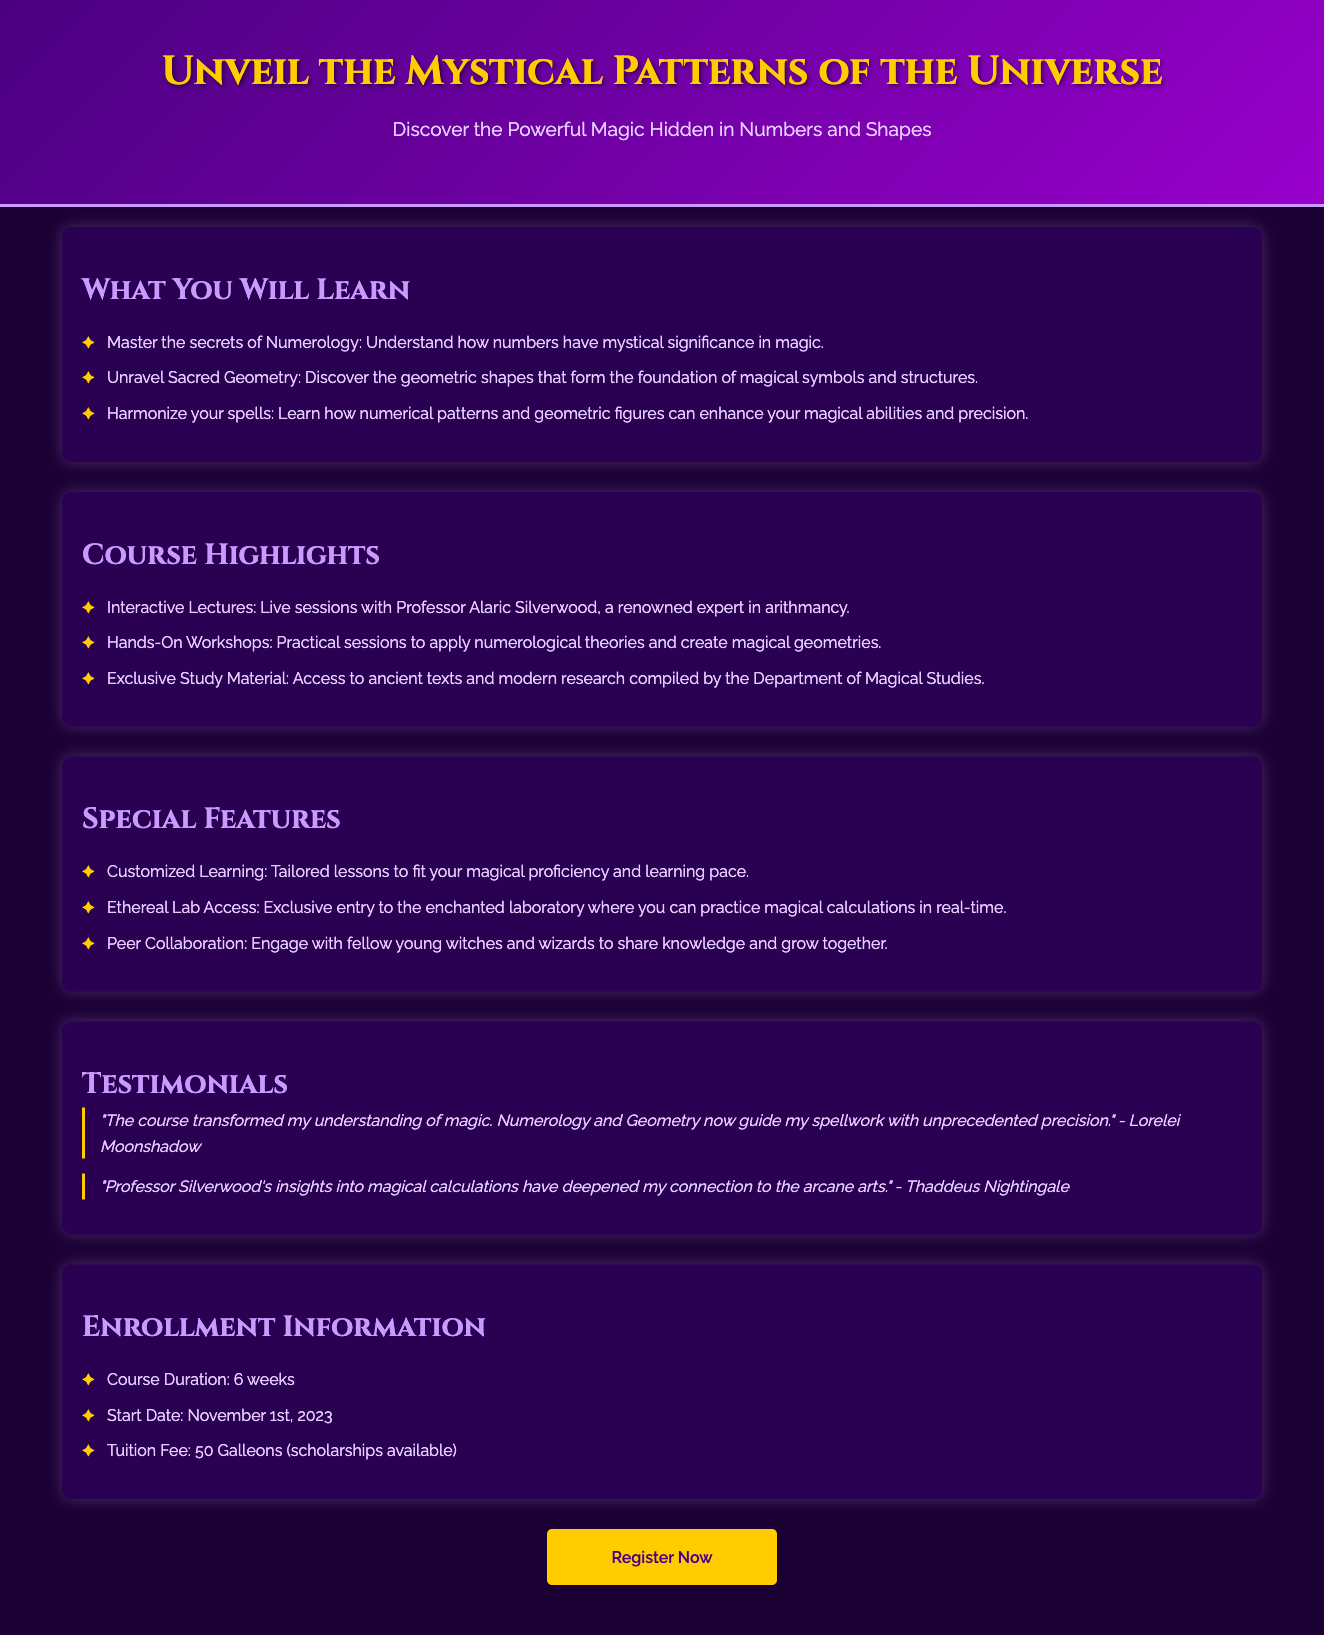What is the title of the course? The title of the course is prominently displayed in the header section of the document.
Answer: Spellbinding Symmetry Who is the instructor of the course? The instructor's name is mentioned in the course highlights section.
Answer: Professor Alaric Silverwood How long is the course duration? The course duration is directly stated in the enrollment information section.
Answer: 6 weeks What is the tuition fee for the course? The tuition fee is clearly listed in the enrollment information section.
Answer: 50 Galleons When does the course start? The start date for the course is provided in the enrollment information section.
Answer: November 1st, 2023 What is one of the special features of the course? The special features are highlighted in a separate section; one feature is mentioned in a bullet point.
Answer: Ethereal Lab Access What type of sessions are included in the course? The types of sessions are outlined in the course highlights section, which specifies the nature of the learning experience.
Answer: Interactive Lectures What is one outcome of the course according to a testimonial? Testimonial excerpts provide insights into the benefits of the course, each stating a specific outcome.
Answer: transformed my understanding of magic How can students register for the course? The method of registration is indicated at the bottom through the call-to-action button.
Answer: Register Now 